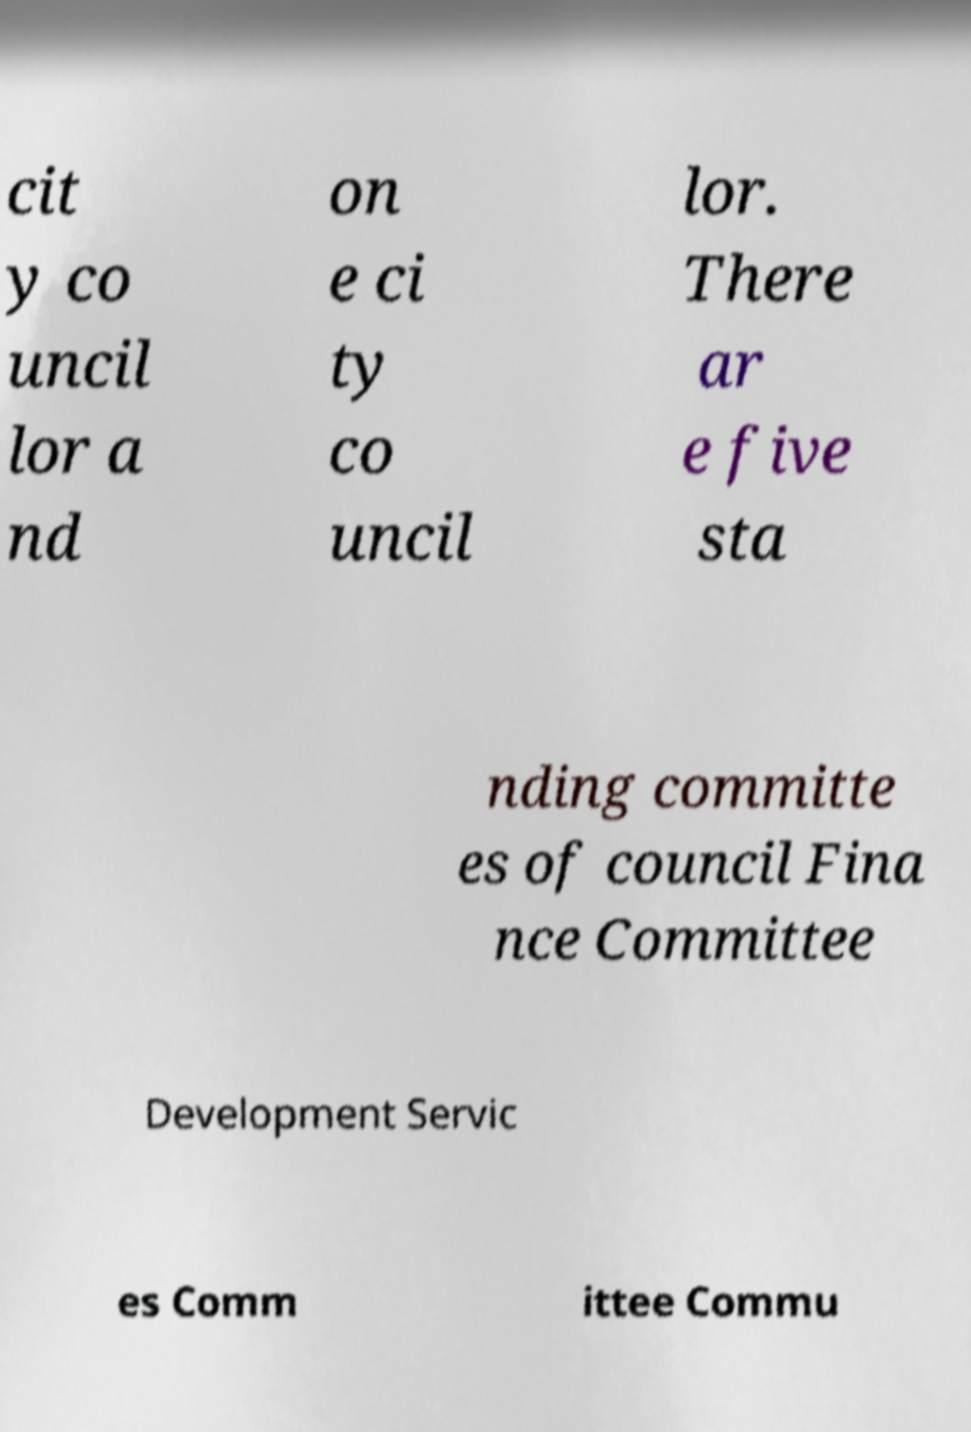I need the written content from this picture converted into text. Can you do that? cit y co uncil lor a nd on e ci ty co uncil lor. There ar e five sta nding committe es of council Fina nce Committee Development Servic es Comm ittee Commu 